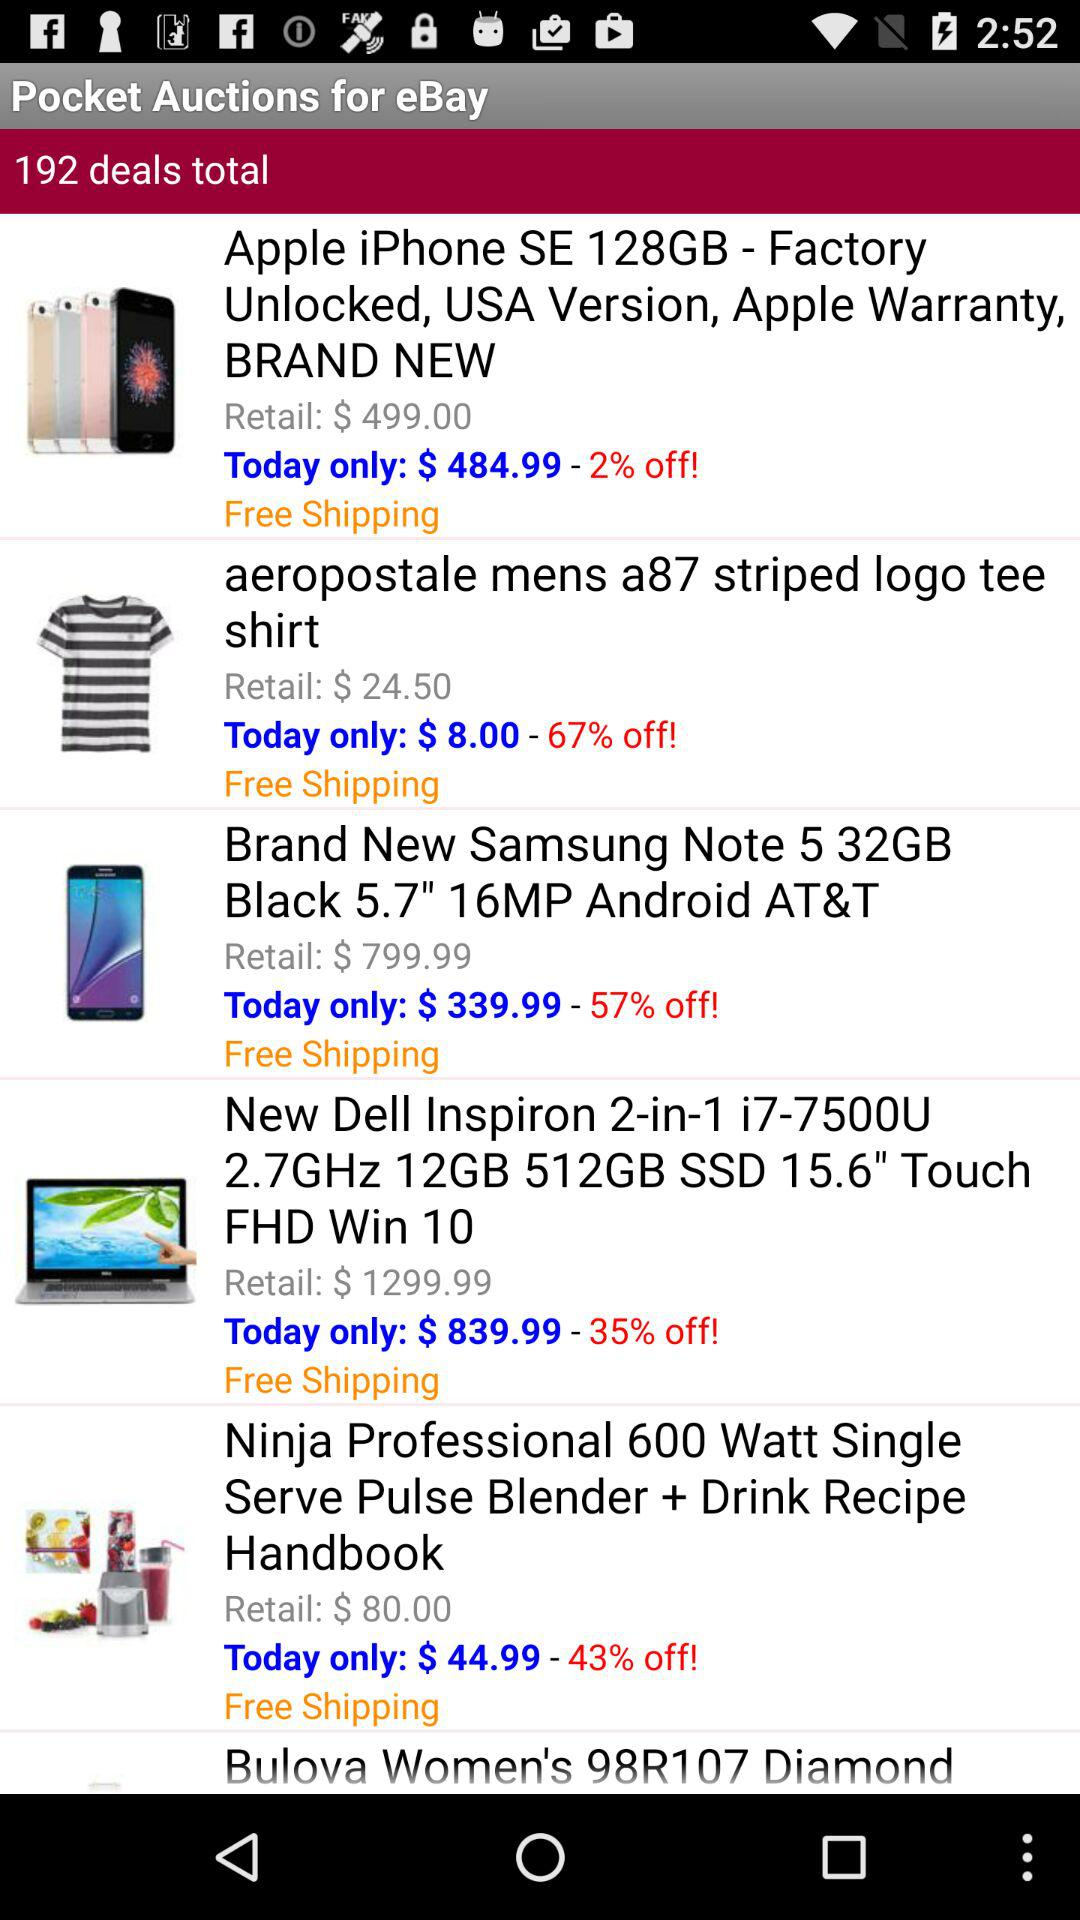What is the total number of deals? The total number of deals is 192. 